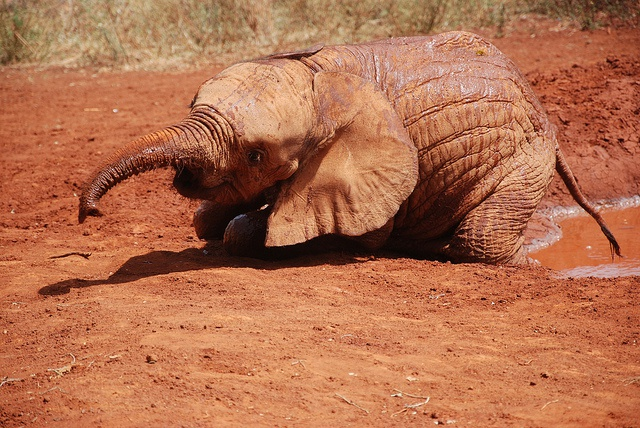Describe the objects in this image and their specific colors. I can see a elephant in tan, black, and maroon tones in this image. 